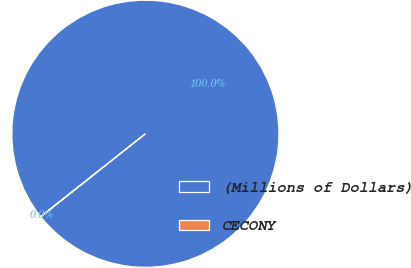<chart> <loc_0><loc_0><loc_500><loc_500><pie_chart><fcel>(Millions of Dollars)<fcel>CECONY<nl><fcel>99.98%<fcel>0.02%<nl></chart> 